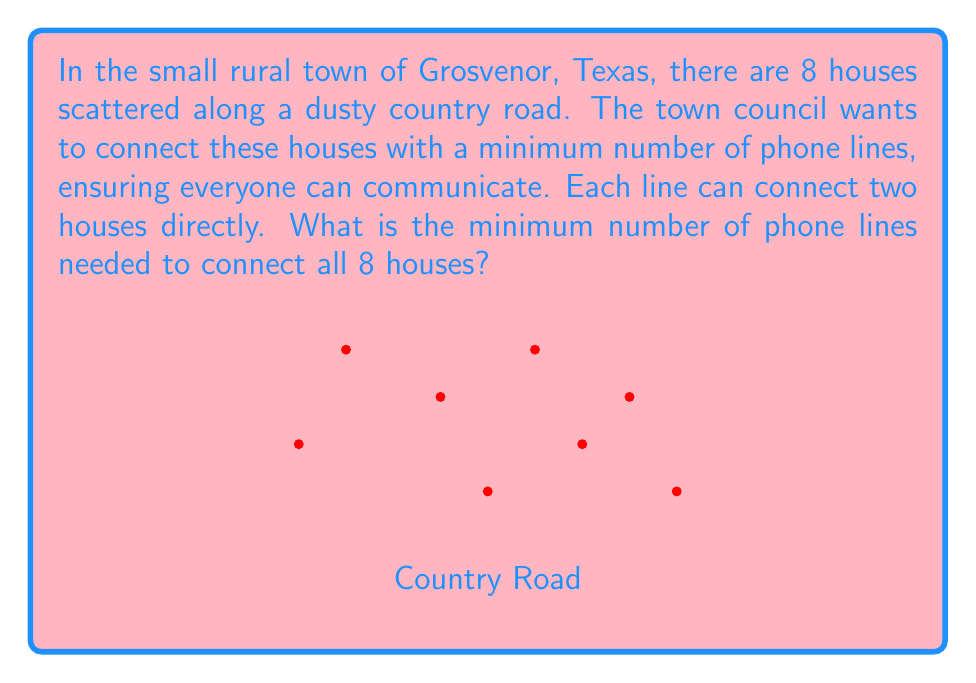Show me your answer to this math problem. To solve this problem, we can use the concept of a minimum spanning tree from graph theory. Here's how we approach it:

1) First, we recognize that the houses and their connections form a graph, where:
   - Each house is a vertex
   - Each phone line is an edge

2) The minimum number of connections needed to link all houses is equal to the number of edges in a minimum spanning tree of this graph.

3) A key property of trees is that the number of edges is always one less than the number of vertices. This is because:
   - A tree has no cycles
   - Each edge connects exactly two vertices
   - All vertices must be connected

4) We can express this mathematically as:

   $$ E = V - 1 $$

   Where $E$ is the number of edges (phone lines) and $V$ is the number of vertices (houses).

5) In this case, we have 8 houses, so $V = 8$.

6) Plugging this into our equation:

   $$ E = 8 - 1 = 7 $$

Therefore, the minimum number of phone lines needed is 7.
Answer: 7 phone lines 